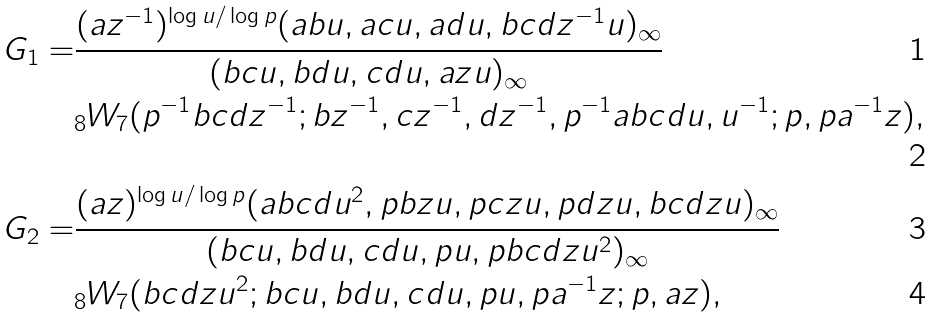<formula> <loc_0><loc_0><loc_500><loc_500>G _ { 1 } = & \cfrac { ( a z ^ { - 1 } ) ^ { \log u / \log p } ( a b u , a c u , a d u , b c d z ^ { - 1 } u ) _ { \infty } } { ( b c u , b d u , c d u , a z u ) _ { \infty } } \\ & _ { 8 } W _ { 7 } ( p ^ { - 1 } b c d z ^ { - 1 } ; b z ^ { - 1 } , c z ^ { - 1 } , d z ^ { - 1 } , p ^ { - 1 } a b c d u , u ^ { - 1 } ; p , p a ^ { - 1 } z ) , \\ G _ { 2 } = & \cfrac { ( a z ) ^ { \log u / \log p } ( a b c d u ^ { 2 } , p b z u , p c z u , p d z u , b c d z u ) _ { \infty } } { ( b c u , b d u , c d u , p u , p b c d z u ^ { 2 } ) _ { \infty } } \\ & _ { 8 } W _ { 7 } ( b c d z u ^ { 2 } ; b c u , b d u , c d u , p u , p a ^ { - 1 } z ; p , a z ) ,</formula> 